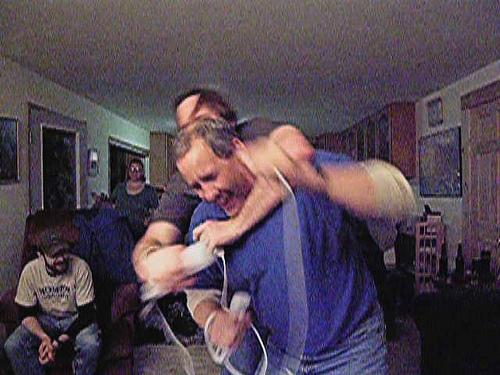What are the two men doing?

Choices:
A) heimlich
B) hugging
C) wrestling
D) assisting wrestling 